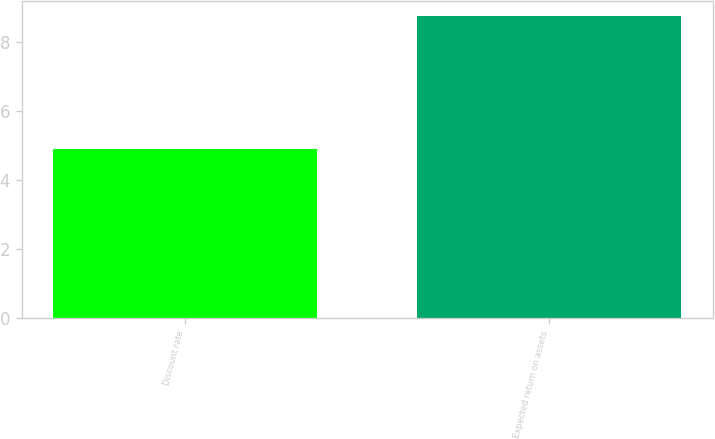<chart> <loc_0><loc_0><loc_500><loc_500><bar_chart><fcel>Discount rate<fcel>Expected return on assets<nl><fcel>4.89<fcel>8.75<nl></chart> 